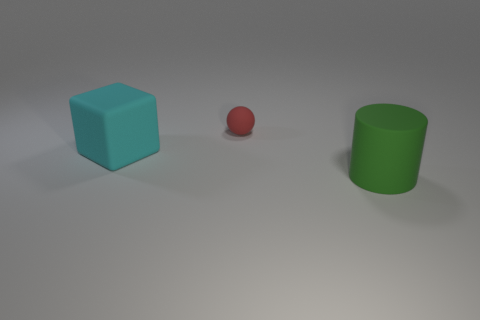What size is the object behind the big object behind the green matte cylinder in front of the red thing?
Keep it short and to the point. Small. Is the number of tiny red things the same as the number of small yellow spheres?
Offer a very short reply. No. There is a large cyan matte block; are there any tiny matte things in front of it?
Your answer should be very brief. No. There is a ball that is made of the same material as the cyan block; what size is it?
Your answer should be compact. Small. How many other matte things have the same shape as the red matte object?
Keep it short and to the point. 0. Does the big green cylinder have the same material as the object behind the large cyan block?
Your answer should be very brief. Yes. Is the number of large matte objects that are on the left side of the cyan cube greater than the number of big green matte cylinders?
Your answer should be very brief. No. Are there any other tiny red balls made of the same material as the sphere?
Your response must be concise. No. Is the big thing in front of the large rubber block made of the same material as the object that is behind the cyan matte block?
Your answer should be compact. Yes. Are there the same number of cylinders behind the large rubber block and red matte things that are in front of the red thing?
Offer a terse response. Yes. 